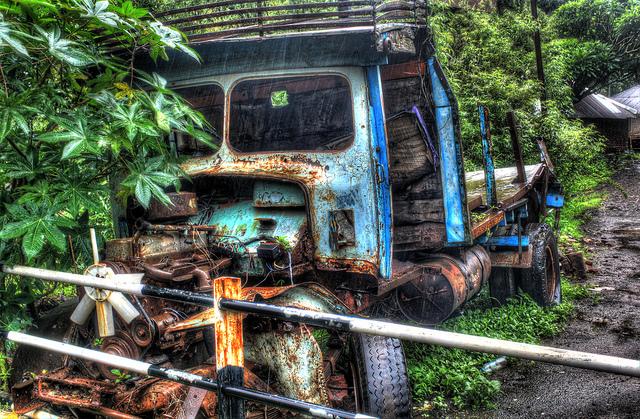Is this photo filtered?
Write a very short answer. Yes. How many leaves are on the tree?
Write a very short answer. Many. Is the truck brand new?
Answer briefly. No. 